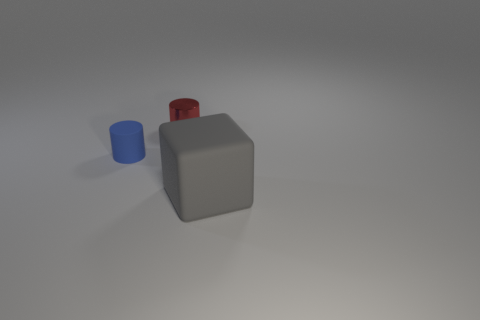Are there fewer big gray cubes that are to the left of the tiny blue matte cylinder than big blue objects?
Give a very brief answer. No. What is the color of the rubber cylinder?
Keep it short and to the point. Blue. There is another small metal thing that is the same shape as the tiny blue object; what is its color?
Offer a terse response. Red. What number of small objects are blue cylinders or gray objects?
Your answer should be very brief. 1. There is a cylinder that is in front of the shiny cylinder; how big is it?
Your response must be concise. Small. There is a tiny cylinder left of the red shiny thing; what number of things are in front of it?
Give a very brief answer. 1. How many tiny objects are made of the same material as the large thing?
Provide a succinct answer. 1. Are there any shiny objects behind the gray rubber block?
Your answer should be compact. Yes. There is a matte cylinder that is the same size as the red metallic cylinder; what is its color?
Provide a short and direct response. Blue. How many objects are either small cylinders in front of the red object or big gray objects?
Make the answer very short. 2. 